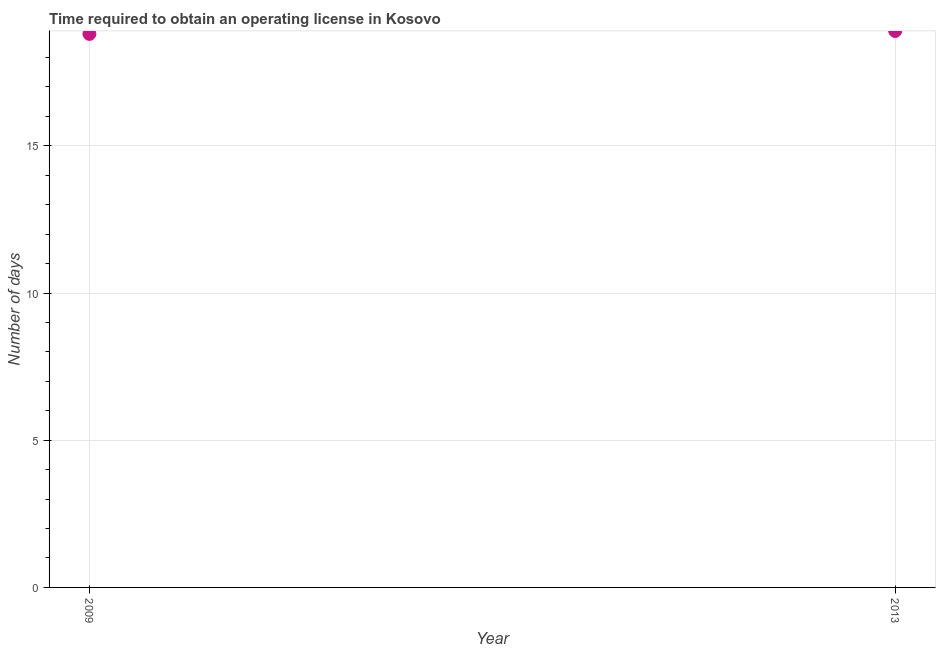What is the number of days to obtain operating license in 2009?
Offer a terse response. 18.8. Across all years, what is the minimum number of days to obtain operating license?
Ensure brevity in your answer.  18.8. In which year was the number of days to obtain operating license maximum?
Offer a terse response. 2013. In which year was the number of days to obtain operating license minimum?
Your answer should be very brief. 2009. What is the sum of the number of days to obtain operating license?
Offer a terse response. 37.7. What is the difference between the number of days to obtain operating license in 2009 and 2013?
Give a very brief answer. -0.1. What is the average number of days to obtain operating license per year?
Offer a very short reply. 18.85. What is the median number of days to obtain operating license?
Provide a succinct answer. 18.85. In how many years, is the number of days to obtain operating license greater than 15 days?
Ensure brevity in your answer.  2. What is the ratio of the number of days to obtain operating license in 2009 to that in 2013?
Your answer should be compact. 0.99. In how many years, is the number of days to obtain operating license greater than the average number of days to obtain operating license taken over all years?
Give a very brief answer. 1. Does the graph contain any zero values?
Offer a very short reply. No. What is the title of the graph?
Provide a short and direct response. Time required to obtain an operating license in Kosovo. What is the label or title of the Y-axis?
Make the answer very short. Number of days. What is the Number of days in 2013?
Provide a succinct answer. 18.9. What is the difference between the Number of days in 2009 and 2013?
Ensure brevity in your answer.  -0.1. 